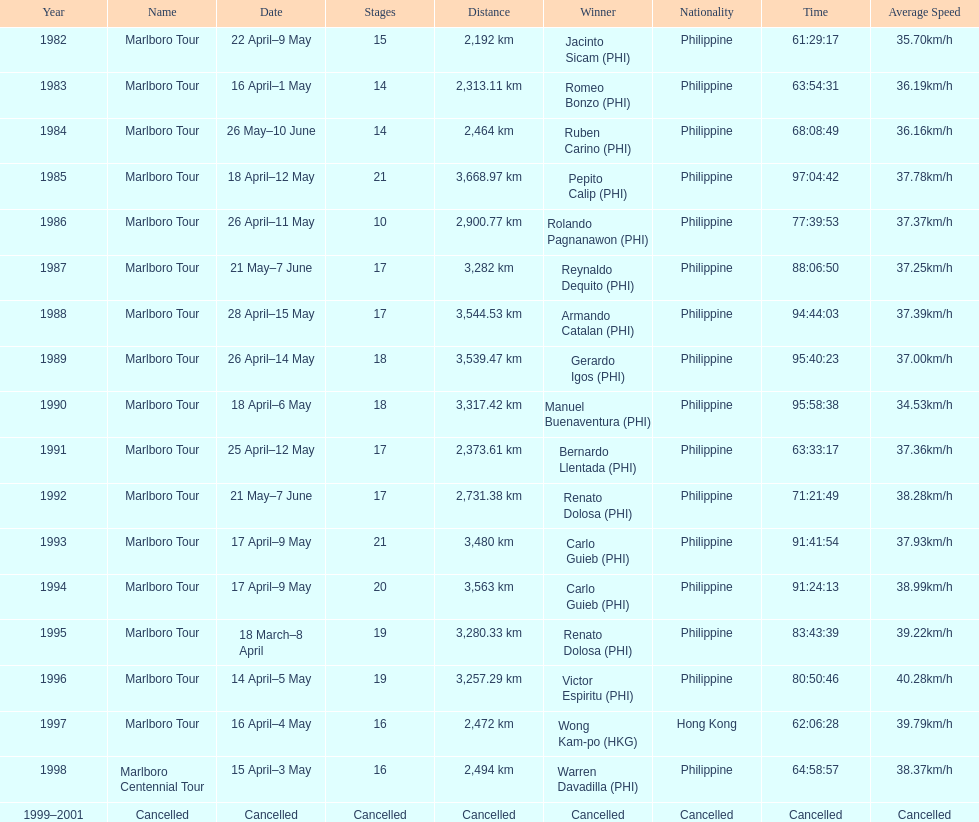How many stages was the 1982 marlboro tour? 15. 